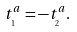<formula> <loc_0><loc_0><loc_500><loc_500>t _ { _ { 1 } } ^ { a } = - t _ { _ { 2 } } ^ { a } { . }</formula> 